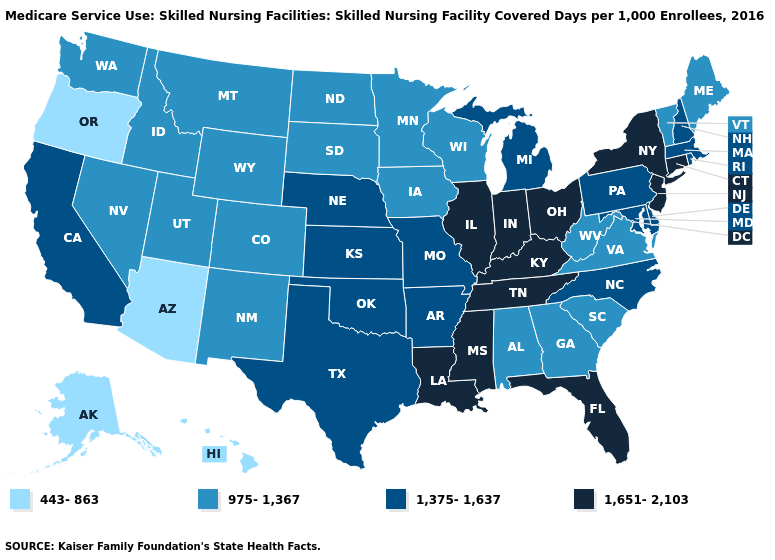What is the value of Oklahoma?
Keep it brief. 1,375-1,637. Name the states that have a value in the range 443-863?
Write a very short answer. Alaska, Arizona, Hawaii, Oregon. Does Wyoming have the highest value in the West?
Concise answer only. No. What is the value of Rhode Island?
Write a very short answer. 1,375-1,637. Name the states that have a value in the range 443-863?
Quick response, please. Alaska, Arizona, Hawaii, Oregon. Does Washington have the lowest value in the West?
Write a very short answer. No. What is the value of Maryland?
Concise answer only. 1,375-1,637. What is the highest value in the South ?
Answer briefly. 1,651-2,103. What is the value of Florida?
Answer briefly. 1,651-2,103. Does Hawaii have the lowest value in the USA?
Concise answer only. Yes. What is the lowest value in states that border Iowa?
Give a very brief answer. 975-1,367. Does Massachusetts have the lowest value in the Northeast?
Concise answer only. No. Which states have the lowest value in the USA?
Write a very short answer. Alaska, Arizona, Hawaii, Oregon. Among the states that border South Dakota , which have the highest value?
Short answer required. Nebraska. Which states have the highest value in the USA?
Keep it brief. Connecticut, Florida, Illinois, Indiana, Kentucky, Louisiana, Mississippi, New Jersey, New York, Ohio, Tennessee. 